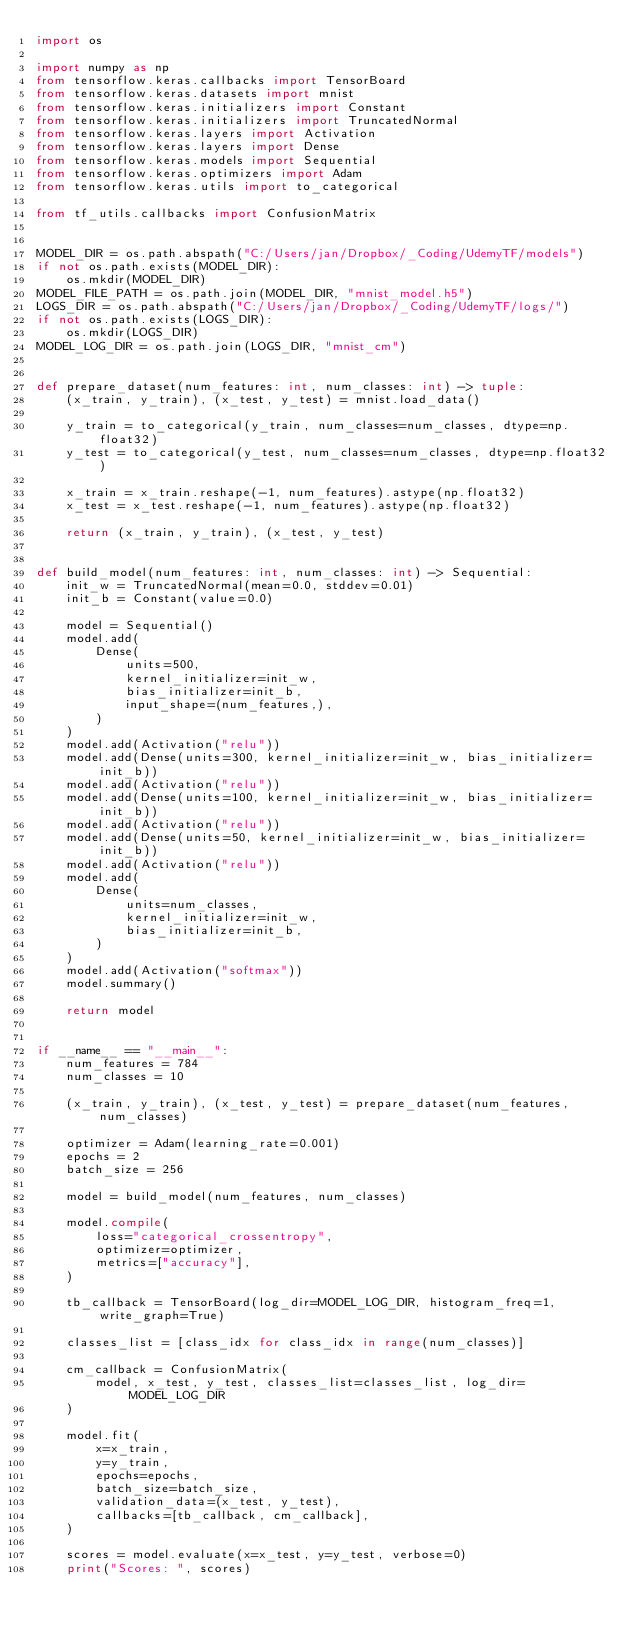<code> <loc_0><loc_0><loc_500><loc_500><_Python_>import os

import numpy as np
from tensorflow.keras.callbacks import TensorBoard
from tensorflow.keras.datasets import mnist
from tensorflow.keras.initializers import Constant
from tensorflow.keras.initializers import TruncatedNormal
from tensorflow.keras.layers import Activation
from tensorflow.keras.layers import Dense
from tensorflow.keras.models import Sequential
from tensorflow.keras.optimizers import Adam
from tensorflow.keras.utils import to_categorical

from tf_utils.callbacks import ConfusionMatrix


MODEL_DIR = os.path.abspath("C:/Users/jan/Dropbox/_Coding/UdemyTF/models")
if not os.path.exists(MODEL_DIR):
    os.mkdir(MODEL_DIR)
MODEL_FILE_PATH = os.path.join(MODEL_DIR, "mnist_model.h5")
LOGS_DIR = os.path.abspath("C:/Users/jan/Dropbox/_Coding/UdemyTF/logs/")
if not os.path.exists(LOGS_DIR):
    os.mkdir(LOGS_DIR)
MODEL_LOG_DIR = os.path.join(LOGS_DIR, "mnist_cm")


def prepare_dataset(num_features: int, num_classes: int) -> tuple:
    (x_train, y_train), (x_test, y_test) = mnist.load_data()

    y_train = to_categorical(y_train, num_classes=num_classes, dtype=np.float32)
    y_test = to_categorical(y_test, num_classes=num_classes, dtype=np.float32)

    x_train = x_train.reshape(-1, num_features).astype(np.float32)
    x_test = x_test.reshape(-1, num_features).astype(np.float32)

    return (x_train, y_train), (x_test, y_test)


def build_model(num_features: int, num_classes: int) -> Sequential:
    init_w = TruncatedNormal(mean=0.0, stddev=0.01)
    init_b = Constant(value=0.0)

    model = Sequential()
    model.add(
        Dense(
            units=500,
            kernel_initializer=init_w,
            bias_initializer=init_b,
            input_shape=(num_features,),
        )
    )
    model.add(Activation("relu"))
    model.add(Dense(units=300, kernel_initializer=init_w, bias_initializer=init_b))
    model.add(Activation("relu"))
    model.add(Dense(units=100, kernel_initializer=init_w, bias_initializer=init_b))
    model.add(Activation("relu"))
    model.add(Dense(units=50, kernel_initializer=init_w, bias_initializer=init_b))
    model.add(Activation("relu"))
    model.add(
        Dense(
            units=num_classes,
            kernel_initializer=init_w,
            bias_initializer=init_b,
        )
    )
    model.add(Activation("softmax"))
    model.summary()

    return model


if __name__ == "__main__":
    num_features = 784
    num_classes = 10

    (x_train, y_train), (x_test, y_test) = prepare_dataset(num_features, num_classes)

    optimizer = Adam(learning_rate=0.001)
    epochs = 2
    batch_size = 256

    model = build_model(num_features, num_classes)

    model.compile(
        loss="categorical_crossentropy",
        optimizer=optimizer,
        metrics=["accuracy"],
    )

    tb_callback = TensorBoard(log_dir=MODEL_LOG_DIR, histogram_freq=1, write_graph=True)

    classes_list = [class_idx for class_idx in range(num_classes)]

    cm_callback = ConfusionMatrix(
        model, x_test, y_test, classes_list=classes_list, log_dir=MODEL_LOG_DIR
    )

    model.fit(
        x=x_train,
        y=y_train,
        epochs=epochs,
        batch_size=batch_size,
        validation_data=(x_test, y_test),
        callbacks=[tb_callback, cm_callback],
    )

    scores = model.evaluate(x=x_test, y=y_test, verbose=0)
    print("Scores: ", scores)
</code> 